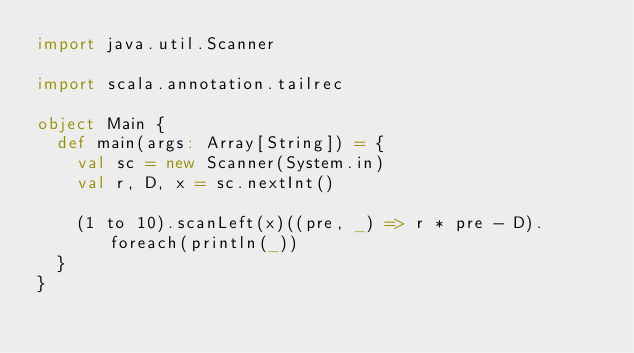Convert code to text. <code><loc_0><loc_0><loc_500><loc_500><_Scala_>import java.util.Scanner

import scala.annotation.tailrec

object Main {
  def main(args: Array[String]) = {
    val sc = new Scanner(System.in)
    val r, D, x = sc.nextInt()

    (1 to 10).scanLeft(x)((pre, _) => r * pre - D).foreach(println(_))
  }
}</code> 